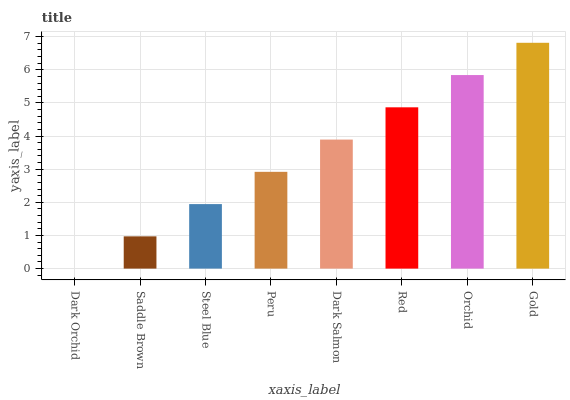Is Dark Orchid the minimum?
Answer yes or no. Yes. Is Gold the maximum?
Answer yes or no. Yes. Is Saddle Brown the minimum?
Answer yes or no. No. Is Saddle Brown the maximum?
Answer yes or no. No. Is Saddle Brown greater than Dark Orchid?
Answer yes or no. Yes. Is Dark Orchid less than Saddle Brown?
Answer yes or no. Yes. Is Dark Orchid greater than Saddle Brown?
Answer yes or no. No. Is Saddle Brown less than Dark Orchid?
Answer yes or no. No. Is Dark Salmon the high median?
Answer yes or no. Yes. Is Peru the low median?
Answer yes or no. Yes. Is Peru the high median?
Answer yes or no. No. Is Dark Salmon the low median?
Answer yes or no. No. 